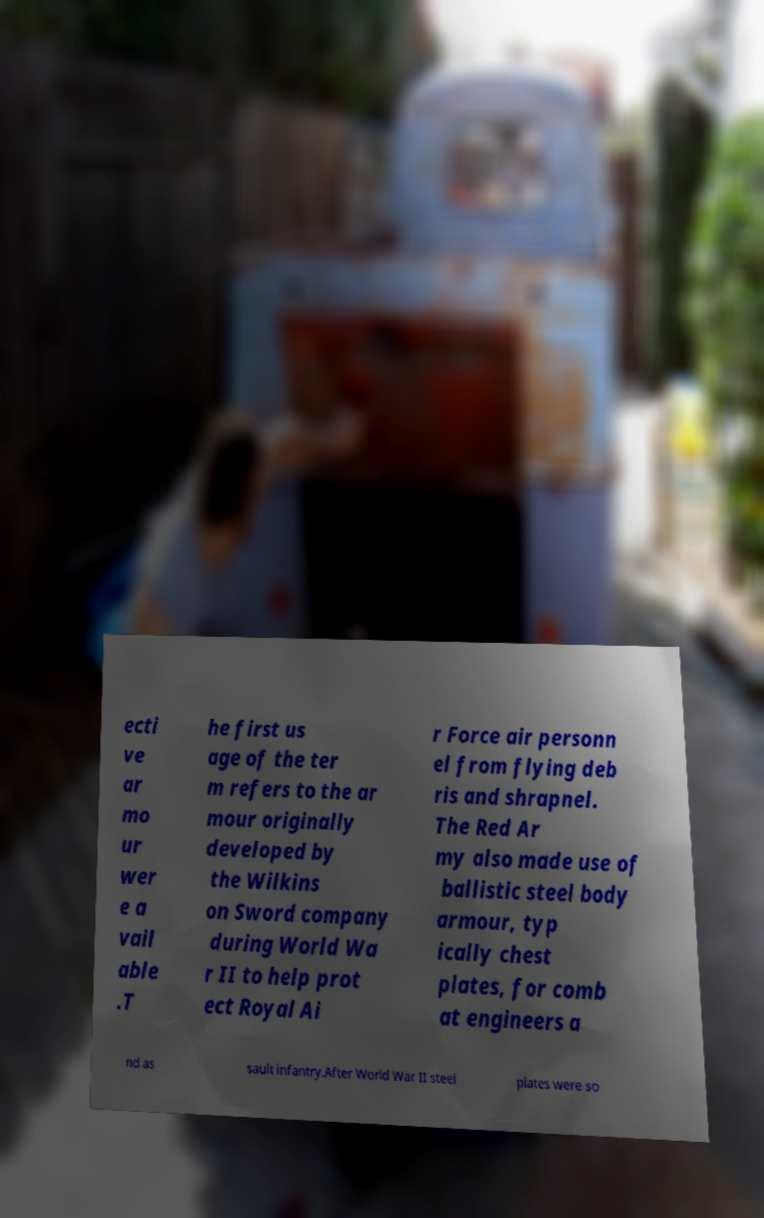Please read and relay the text visible in this image. What does it say? ecti ve ar mo ur wer e a vail able .T he first us age of the ter m refers to the ar mour originally developed by the Wilkins on Sword company during World Wa r II to help prot ect Royal Ai r Force air personn el from flying deb ris and shrapnel. The Red Ar my also made use of ballistic steel body armour, typ ically chest plates, for comb at engineers a nd as sault infantry.After World War II steel plates were so 